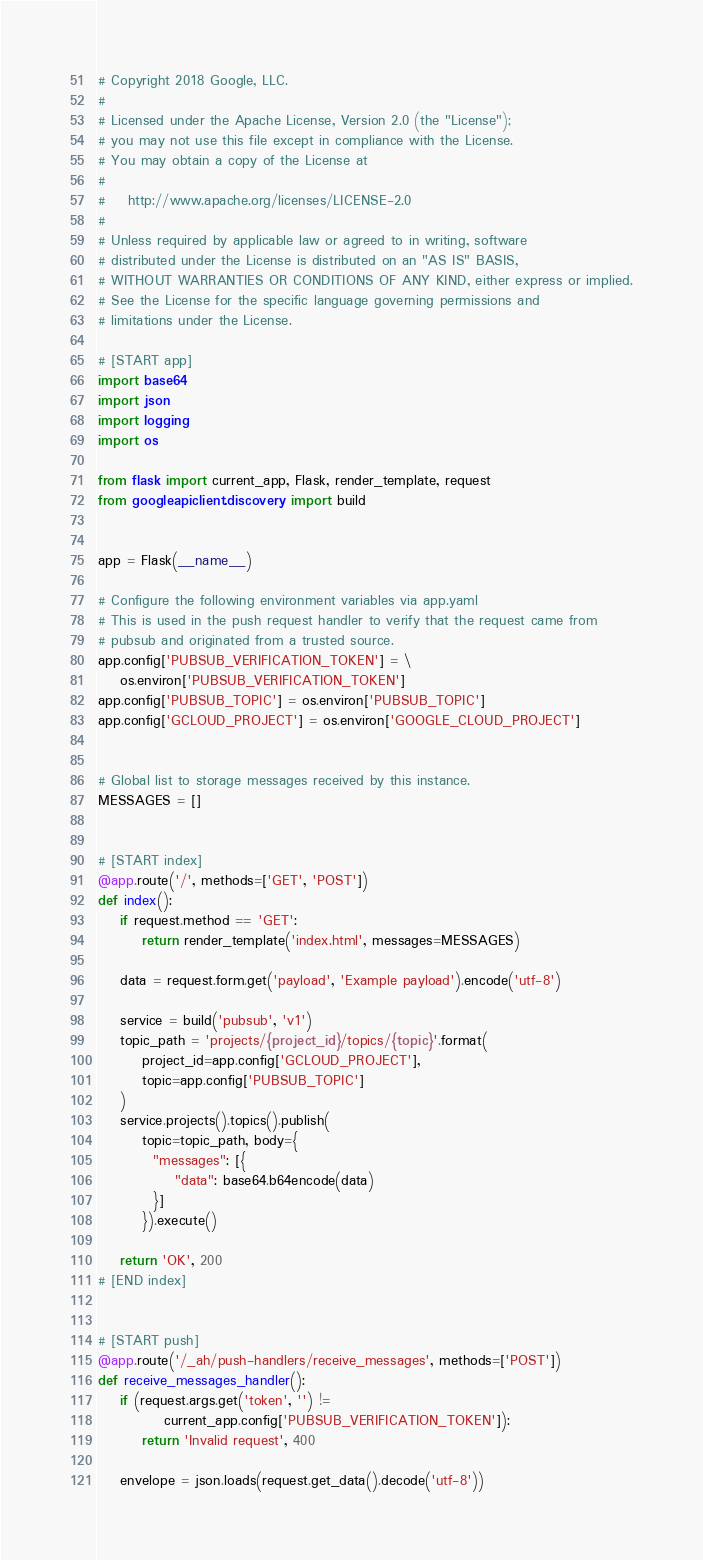Convert code to text. <code><loc_0><loc_0><loc_500><loc_500><_Python_># Copyright 2018 Google, LLC.
#
# Licensed under the Apache License, Version 2.0 (the "License");
# you may not use this file except in compliance with the License.
# You may obtain a copy of the License at
#
#    http://www.apache.org/licenses/LICENSE-2.0
#
# Unless required by applicable law or agreed to in writing, software
# distributed under the License is distributed on an "AS IS" BASIS,
# WITHOUT WARRANTIES OR CONDITIONS OF ANY KIND, either express or implied.
# See the License for the specific language governing permissions and
# limitations under the License.

# [START app]
import base64
import json
import logging
import os

from flask import current_app, Flask, render_template, request
from googleapiclient.discovery import build


app = Flask(__name__)

# Configure the following environment variables via app.yaml
# This is used in the push request handler to verify that the request came from
# pubsub and originated from a trusted source.
app.config['PUBSUB_VERIFICATION_TOKEN'] = \
    os.environ['PUBSUB_VERIFICATION_TOKEN']
app.config['PUBSUB_TOPIC'] = os.environ['PUBSUB_TOPIC']
app.config['GCLOUD_PROJECT'] = os.environ['GOOGLE_CLOUD_PROJECT']


# Global list to storage messages received by this instance.
MESSAGES = []


# [START index]
@app.route('/', methods=['GET', 'POST'])
def index():
    if request.method == 'GET':
        return render_template('index.html', messages=MESSAGES)

    data = request.form.get('payload', 'Example payload').encode('utf-8')

    service = build('pubsub', 'v1')
    topic_path = 'projects/{project_id}/topics/{topic}'.format(
        project_id=app.config['GCLOUD_PROJECT'],
        topic=app.config['PUBSUB_TOPIC']
    )
    service.projects().topics().publish(
        topic=topic_path, body={
          "messages": [{
              "data": base64.b64encode(data)
          }]
        }).execute()

    return 'OK', 200
# [END index]


# [START push]
@app.route('/_ah/push-handlers/receive_messages', methods=['POST'])
def receive_messages_handler():
    if (request.args.get('token', '') !=
            current_app.config['PUBSUB_VERIFICATION_TOKEN']):
        return 'Invalid request', 400

    envelope = json.loads(request.get_data().decode('utf-8'))</code> 